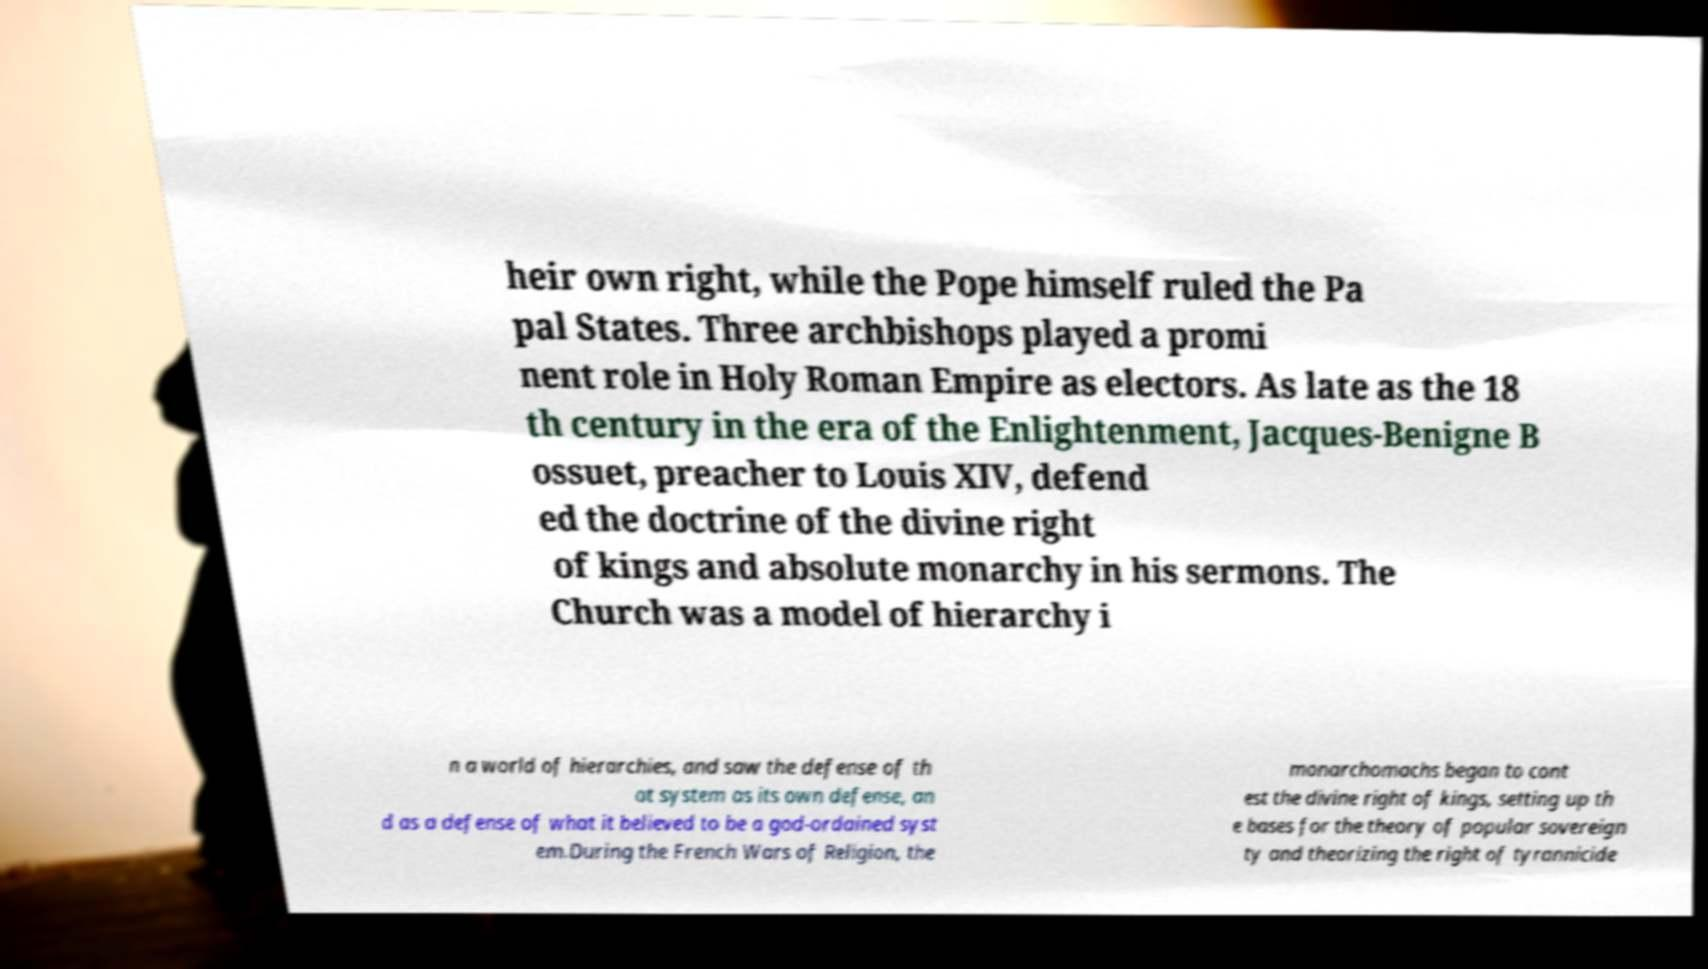Could you assist in decoding the text presented in this image and type it out clearly? heir own right, while the Pope himself ruled the Pa pal States. Three archbishops played a promi nent role in Holy Roman Empire as electors. As late as the 18 th century in the era of the Enlightenment, Jacques-Benigne B ossuet, preacher to Louis XIV, defend ed the doctrine of the divine right of kings and absolute monarchy in his sermons. The Church was a model of hierarchy i n a world of hierarchies, and saw the defense of th at system as its own defense, an d as a defense of what it believed to be a god-ordained syst em.During the French Wars of Religion, the monarchomachs began to cont est the divine right of kings, setting up th e bases for the theory of popular sovereign ty and theorizing the right of tyrannicide 